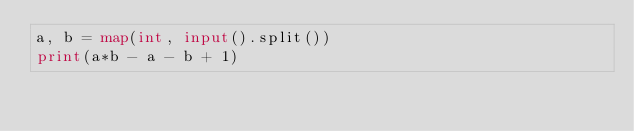<code> <loc_0><loc_0><loc_500><loc_500><_Python_>a, b = map(int, input().split())
print(a*b - a - b + 1)</code> 